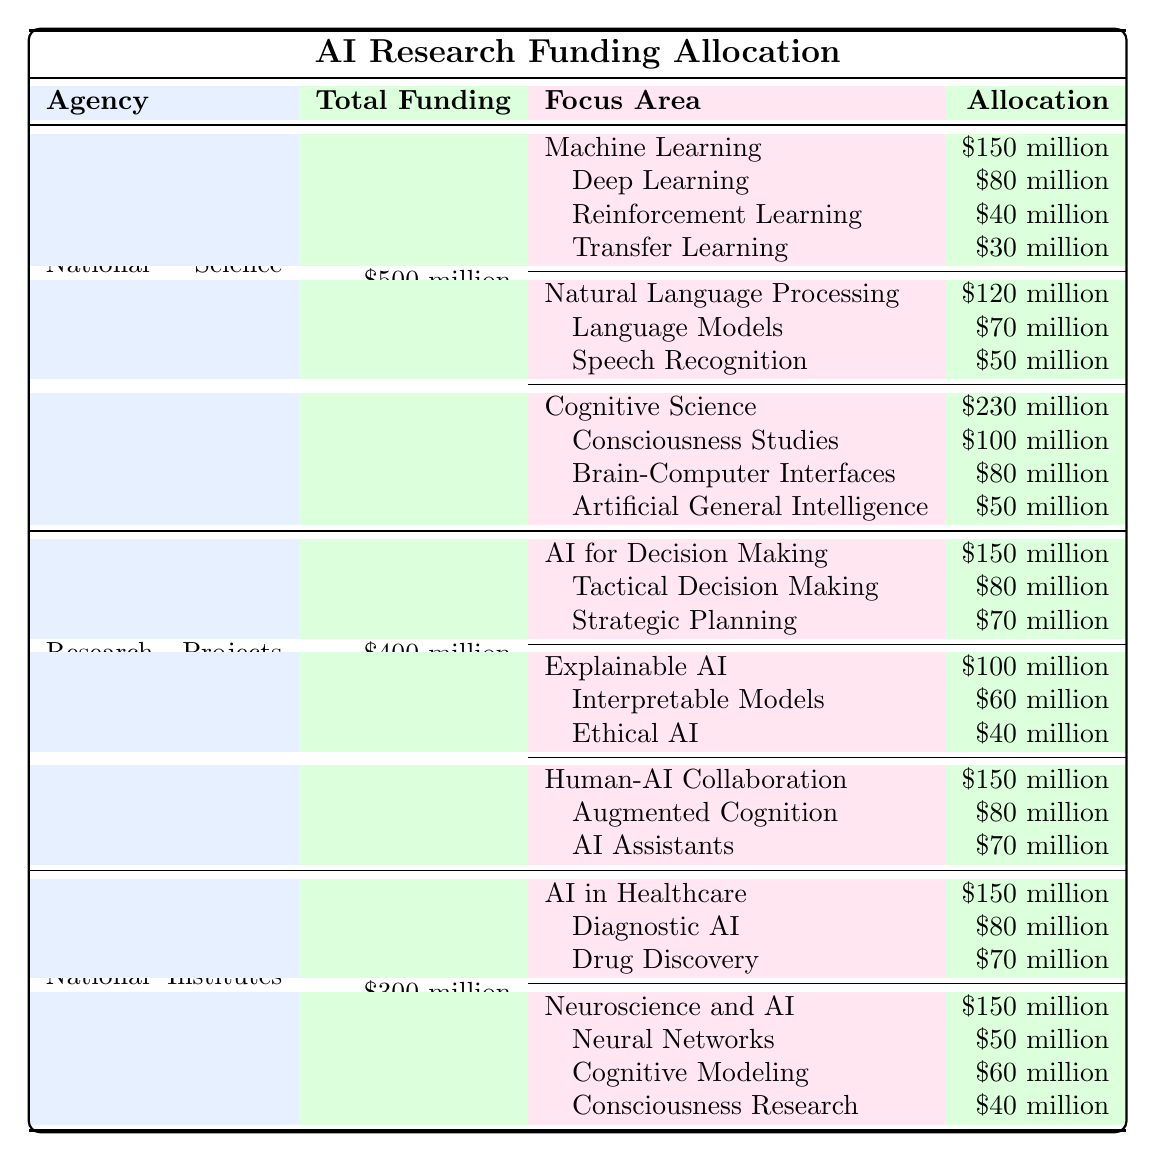What is the total funding allocated by the National Science Foundation (NSF)? The table shows that the total funding allocated by the NSF is listed directly as $500 million.
Answer: $500 million How much funding is allocated to Natural Language Processing by DARPA? According to the table, the allocation for Natural Language Processing is not directly mentioned; instead, the table shows DARPA's focus on Explainable AI with an allocation of $100 million, but no specific area called Natural Language Processing is listed under DARPA.
Answer: Not applicable What is the focus area with the highest allocation from the NIH? By examining the table, the focus area "AI in Healthcare" and "Neuroscience and AI" both have allocations of $150 million, but "Neuroscience and AI" encompasses more sub-areas. To find the highest specific area, the top individual area under NIH is still AI in Healthcare at $150 million.
Answer: AI in Healthcare Which agency has the highest funding for Consciousness Studies? The table specifies that the NSF allocates $100 million towards Consciousness Studies, which is higher than the funding amounts for Consciousness Research at NIH, which is $40 million. Therefore, NSF has the highest funding for Consciousness Studies.
Answer: National Science Foundation (NSF) What is the total funding for Cognitive Science under the NSF? The allocation for Cognitive Science under NSF is listed as $230 million. This is the total funding for that focus area and includes its sub-areas' allocations.
Answer: $230 million What is the sum of all funding allocated to AI for Decision Making and Human-AI Collaboration by DARPA? The funding for AI for Decision Making is $150 million and for Human-AI Collaboration is also $150 million. Adding these amounts together gives 150 + 150 = 300 million.
Answer: $300 million Which sub-area receives more funding, Speech Recognition or Drug Discovery? The table shows Speech Recognition has $50 million while Drug Discovery has $70 million. Since 70 million is greater than 50 million, Drug Discovery has more funding.
Answer: Drug Discovery How much total funding is allocated to Machine Learning across all included agencies? Under NSF, Machine Learning has a total allocation of $150 million, and no additional information about Machine Learning allocations from DARPA or NIH is provided. Thus, the total across all agencies for this area remains at $150 million.
Answer: $150 million Is the funding for AI in Healthcare equal to the funding for Explainable AI? The funding for AI in Healthcare under NIH is $150 million while Explainable AI under DARPA is $100 million. Since 150 million is greater than 100 million, they are not equal.
Answer: No What percentage of the total NIH funding is dedicated to Consciousness Research? NIH has a total funding of $300 million, and Consciousness Research receives $40 million. Calculating the percentage gives (40 / 300) * 100 = 13.33%.
Answer: 13.33% 